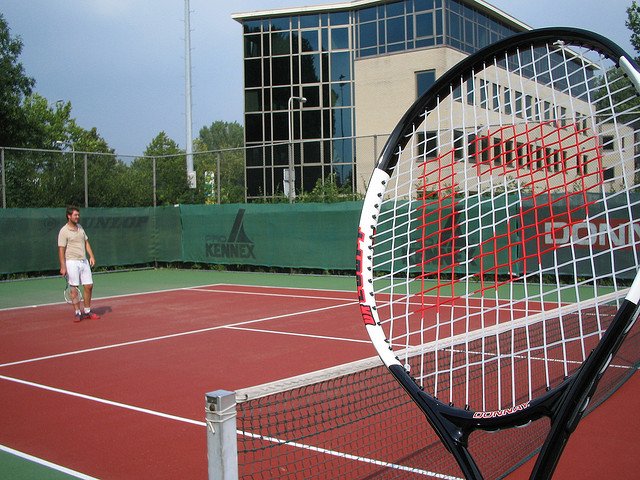Who plays this sport?
A. marian hossa
B. serena williams
C. bo jackson
D. pele The sport depicted in the image is tennis, which is skillfully played by option B, Serena Williams, who is renowned for her powerful style of play and multiple Grand Slam titles. 